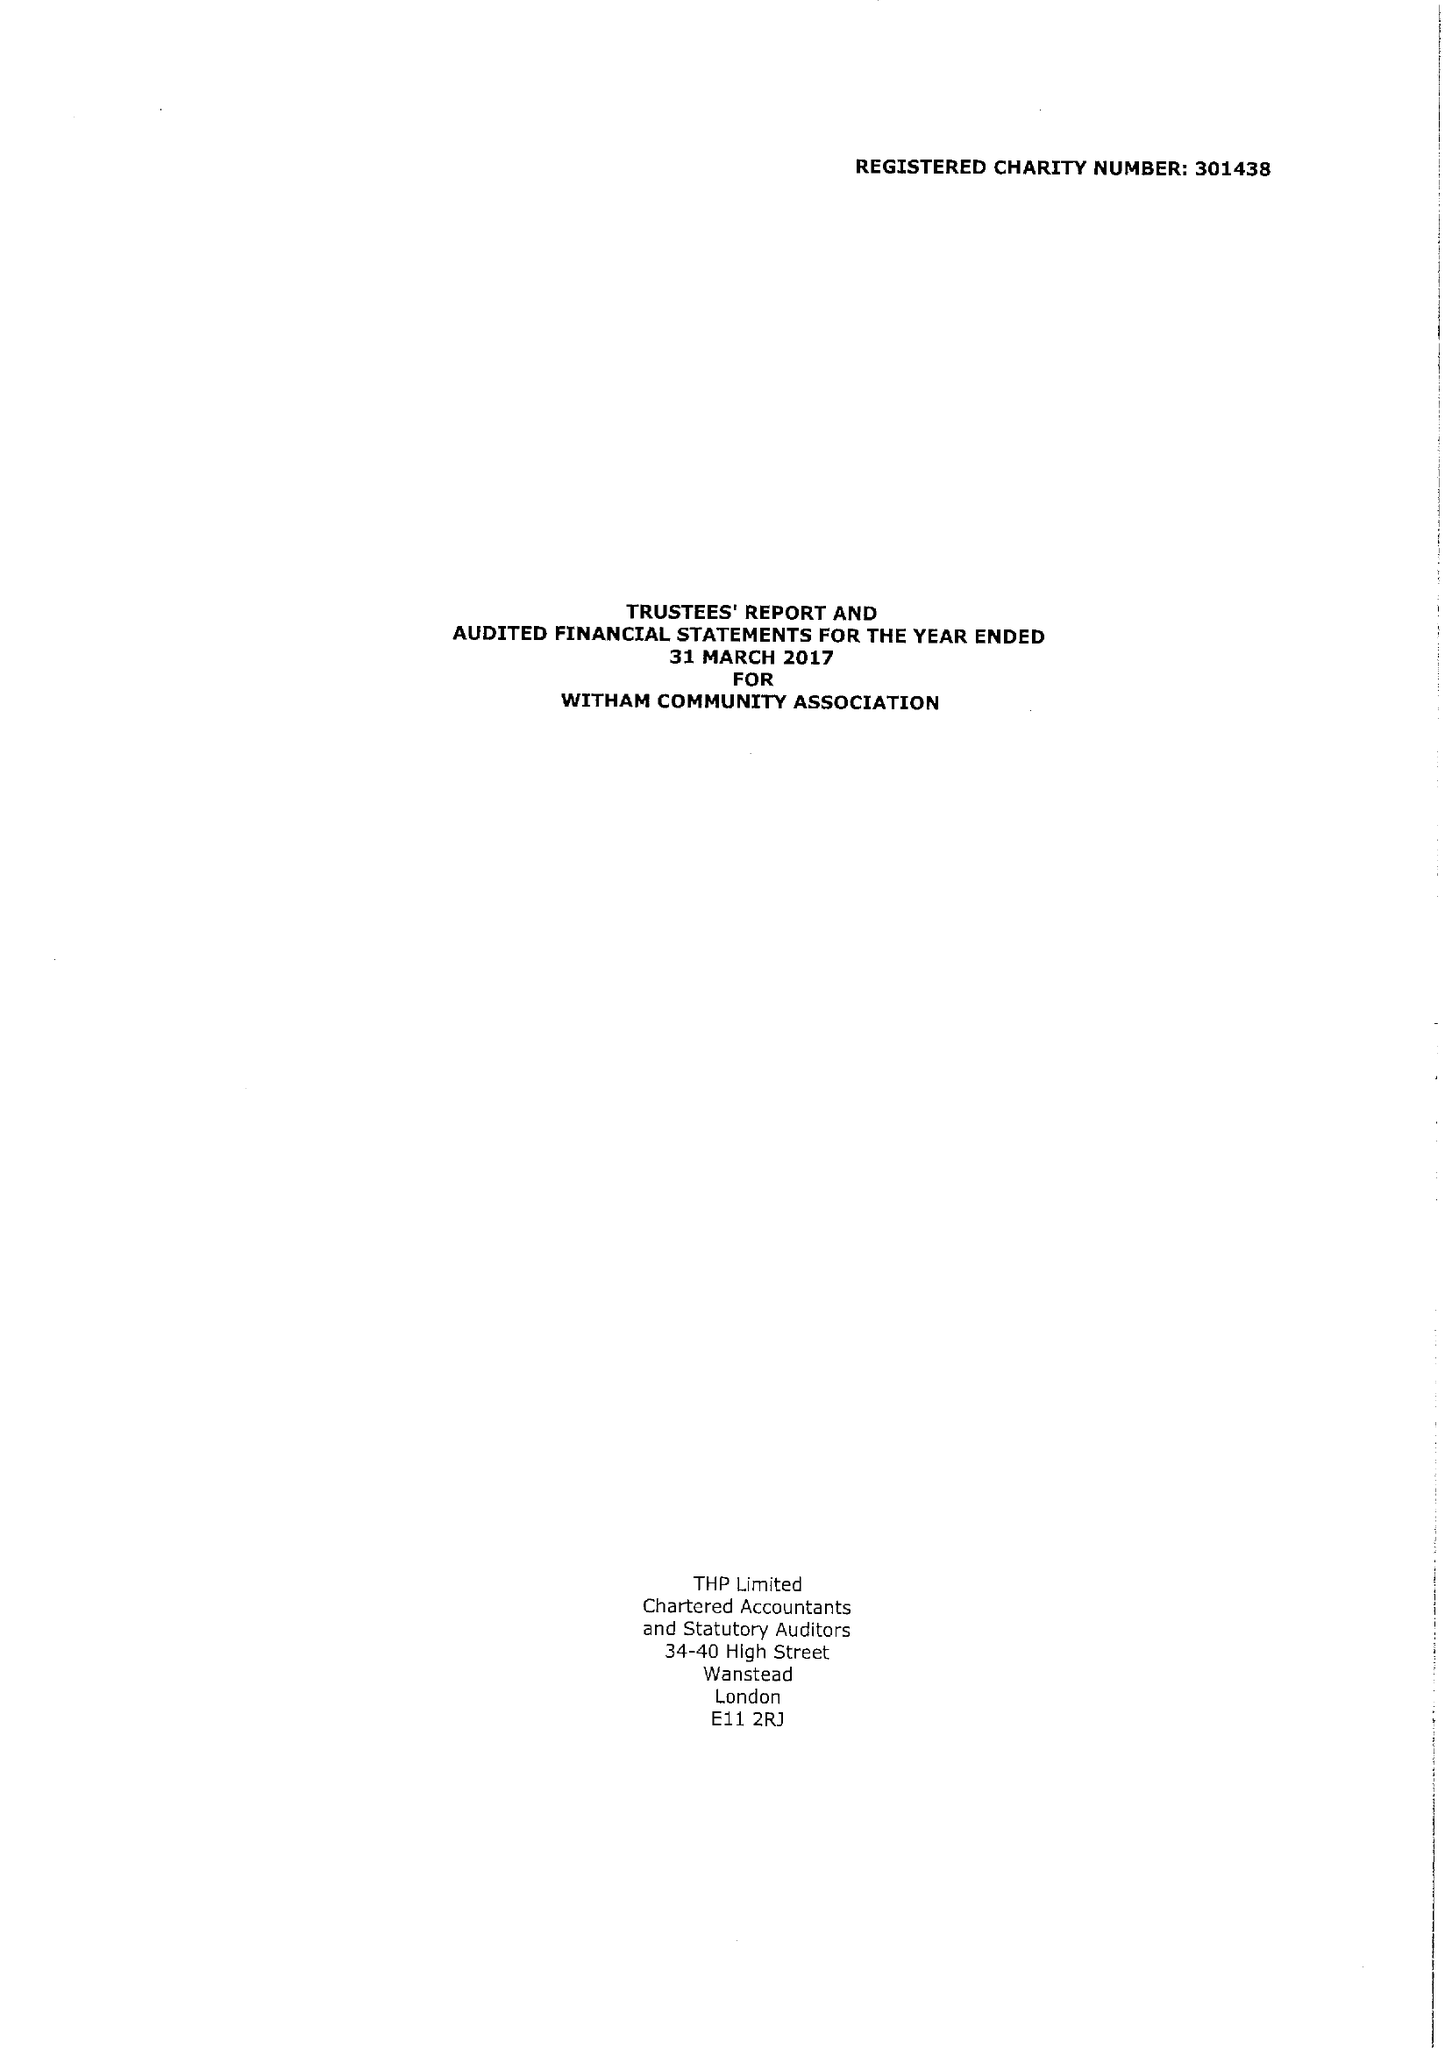What is the value for the address__postcode?
Answer the question using a single word or phrase. CM8 2EZ 